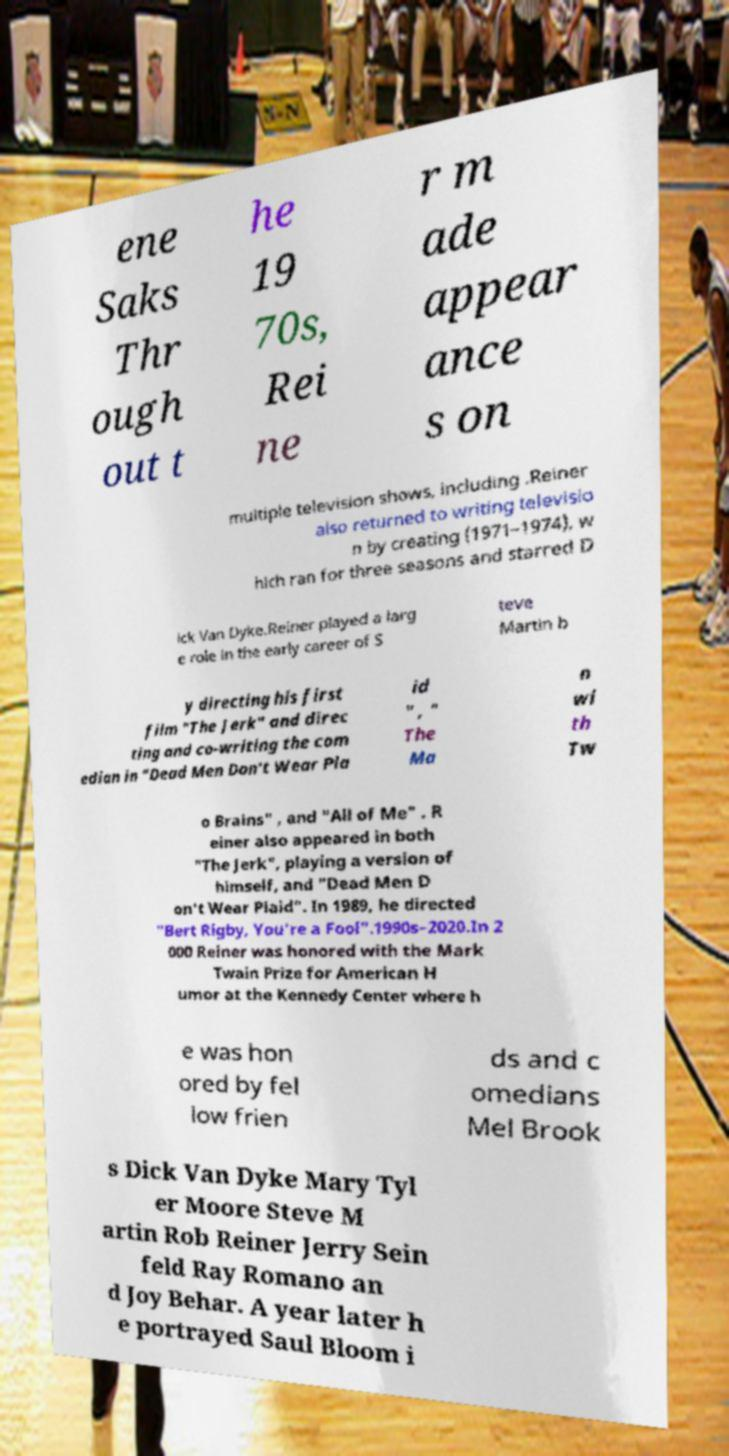For documentation purposes, I need the text within this image transcribed. Could you provide that? ene Saks Thr ough out t he 19 70s, Rei ne r m ade appear ance s on multiple television shows, including .Reiner also returned to writing televisio n by creating (1971–1974), w hich ran for three seasons and starred D ick Van Dyke.Reiner played a larg e role in the early career of S teve Martin b y directing his first film "The Jerk" and direc ting and co-writing the com edian in "Dead Men Don't Wear Pla id " , " The Ma n wi th Tw o Brains" , and "All of Me" . R einer also appeared in both "The Jerk", playing a version of himself, and "Dead Men D on't Wear Plaid". In 1989, he directed "Bert Rigby, You're a Fool".1990s–2020.In 2 000 Reiner was honored with the Mark Twain Prize for American H umor at the Kennedy Center where h e was hon ored by fel low frien ds and c omedians Mel Brook s Dick Van Dyke Mary Tyl er Moore Steve M artin Rob Reiner Jerry Sein feld Ray Romano an d Joy Behar. A year later h e portrayed Saul Bloom i 